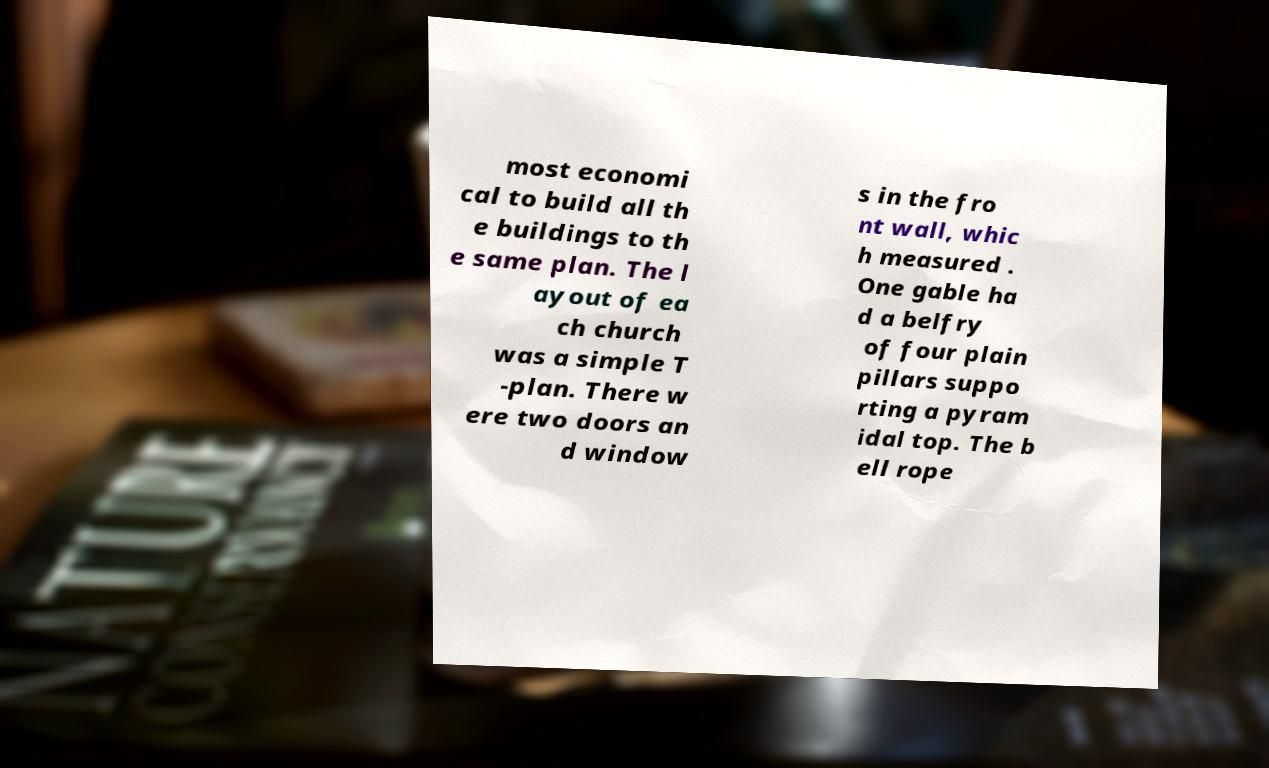For documentation purposes, I need the text within this image transcribed. Could you provide that? most economi cal to build all th e buildings to th e same plan. The l ayout of ea ch church was a simple T -plan. There w ere two doors an d window s in the fro nt wall, whic h measured . One gable ha d a belfry of four plain pillars suppo rting a pyram idal top. The b ell rope 